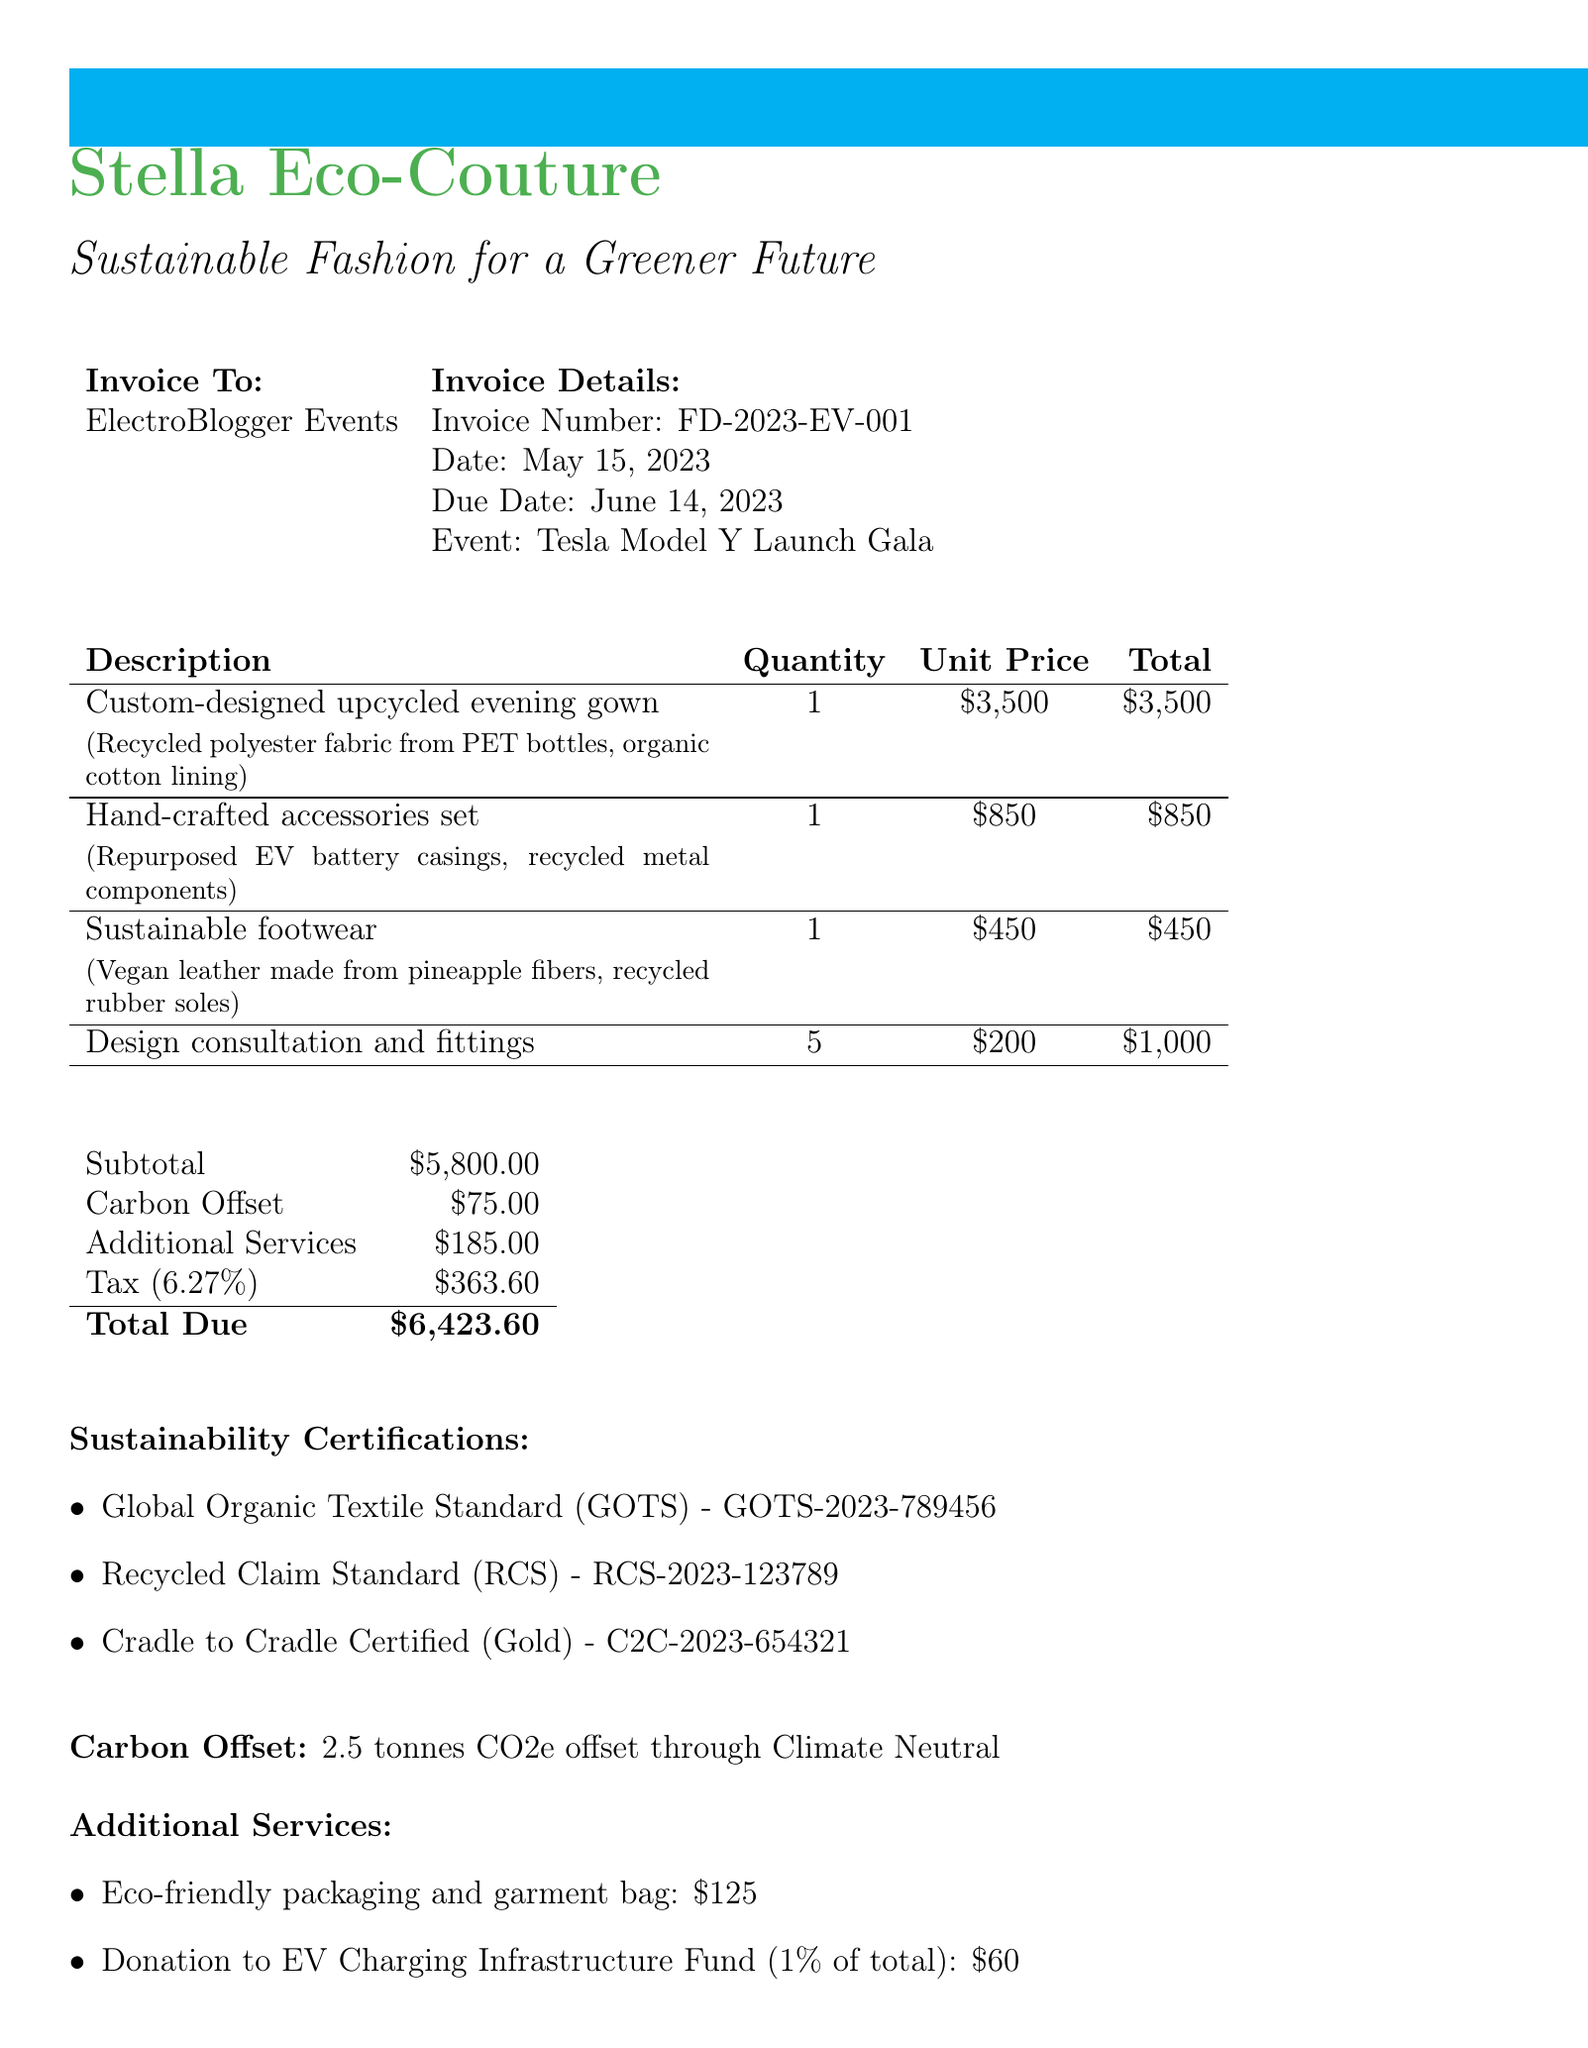What is the invoice number? The invoice number is explicitly stated in the document.
Answer: FD-2023-EV-001 What is the total due amount? The total due amount is the final amount that needs to be paid as calculated in the invoice.
Answer: $6,423.60 What client is the invoice issued to? The document specifies the client to whom the invoice is issued.
Answer: ElectroBlogger Events What materials are used for the sustainable footwear? The document lists the materials used for the sustainable footwear item.
Answer: Vegan leather made from pineapple fibers, recycled rubber soles How many design consultations and fittings were conducted? The quantity of design consultations and fittings is detailed in the line items.
Answer: 5 What is the carbon offset amount? The carbon offset amount is listed separately in the invoice details.
Answer: $75.00 What is the percentage donation to the EV Charging Infrastructure Fund? The invoice specifies the percentage for the donation to the fund as mentioned in the document.
Answer: 1% of total invoice Which certification level is held for Cradle to Cradle Certified? The document details the certification level for Cradle to Cradle certification.
Answer: Gold What method of payment is accepted? The payment terms specify the acceptable methods of payment.
Answer: Bank transfer or PayPal 